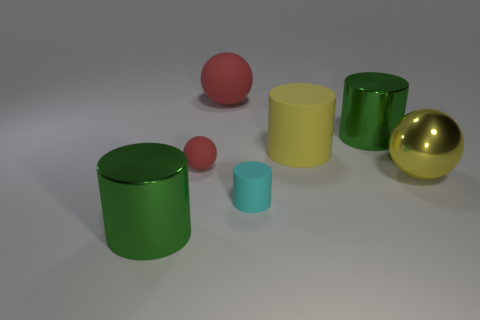Add 2 large green cylinders. How many objects exist? 9 Subtract all cylinders. How many objects are left? 3 Subtract all green metal objects. Subtract all large yellow balls. How many objects are left? 4 Add 4 matte cylinders. How many matte cylinders are left? 6 Add 4 big things. How many big things exist? 9 Subtract 0 brown blocks. How many objects are left? 7 